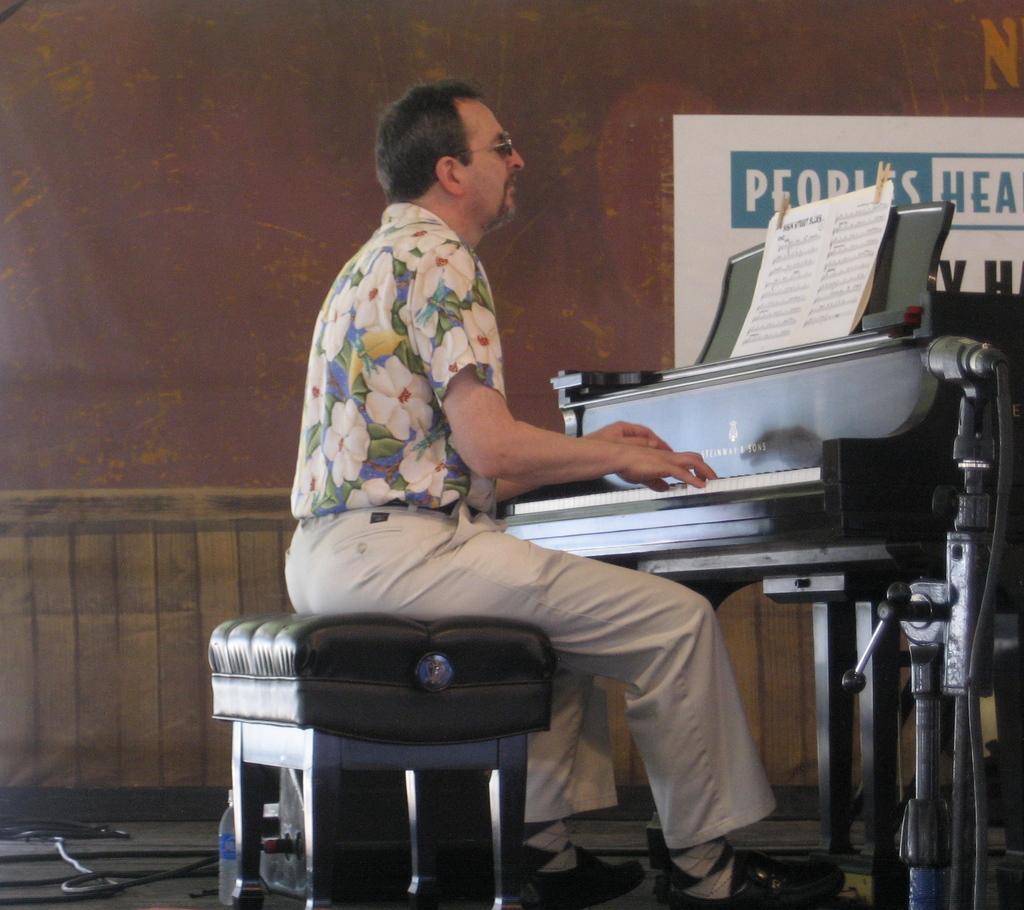Can you describe this image briefly? Here we can see a man sitting on a stool with a piano in front of him and he is playing the piano with musical notes in front present in front of him 